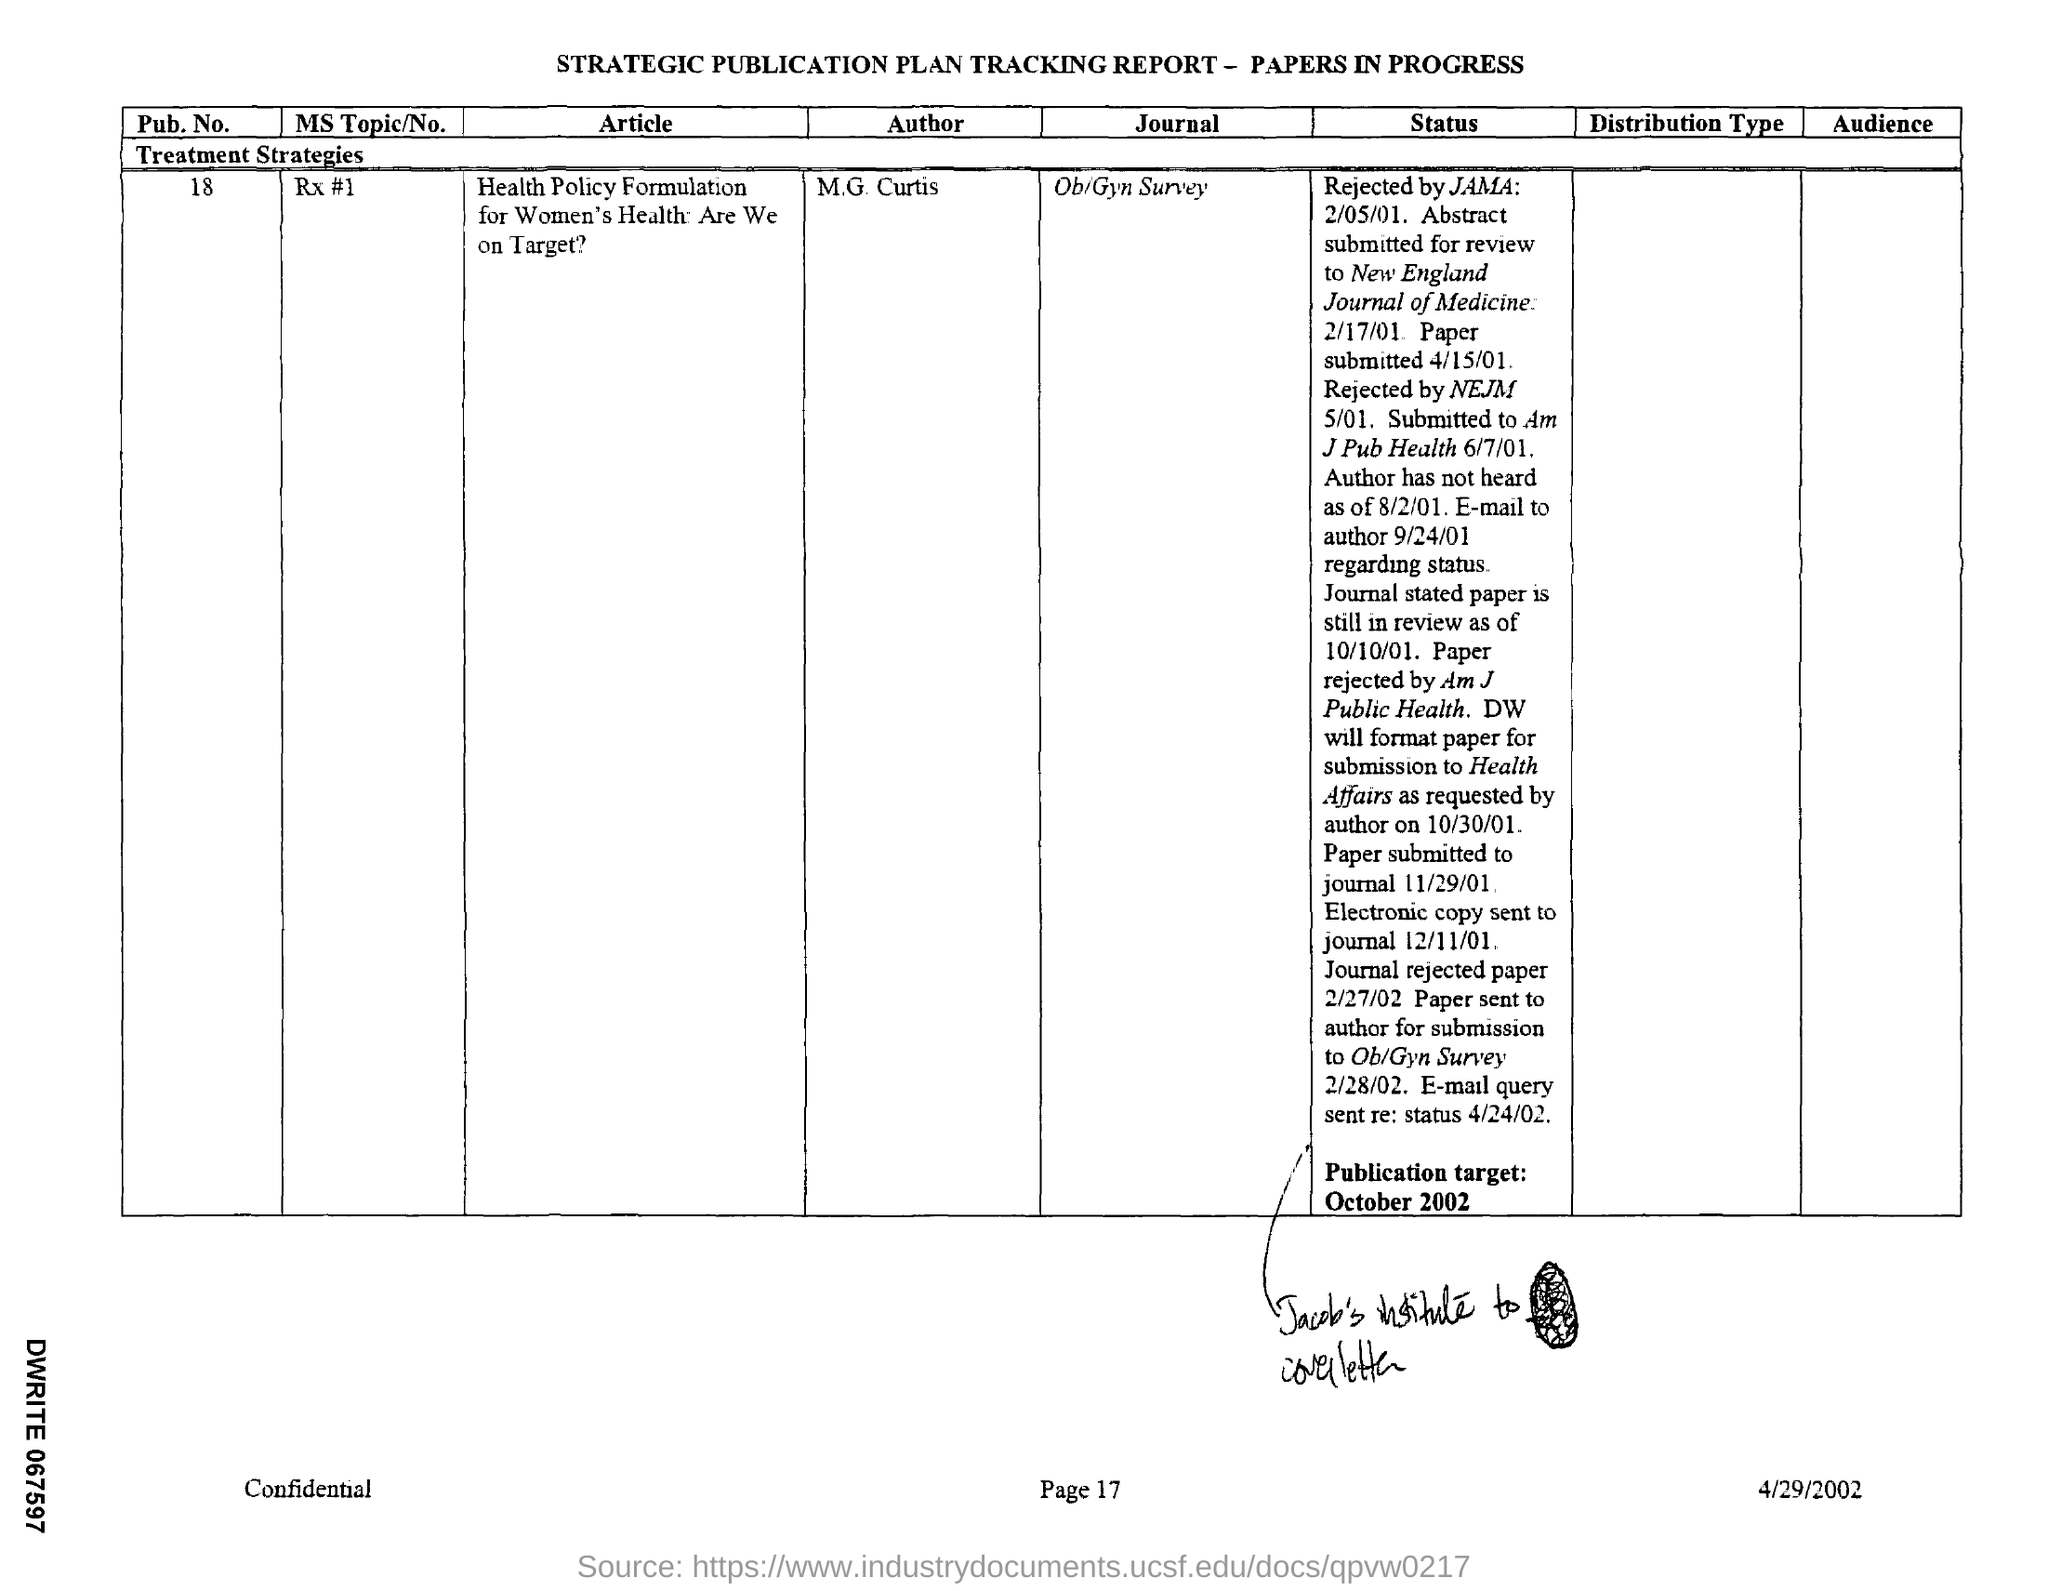Specify some key components in this picture. The publication target for the report is October 2002. The journal mentioned in the tracking report is the Ob/Gyn Survey. The given tracking report mentions a "pub .no." in its content. The given tracking report mentions the name of an author as M.G. Curtis. The article titled 'Health Policy Formulation for women's health' is mentioned in the given tracking report, and we are on target. 